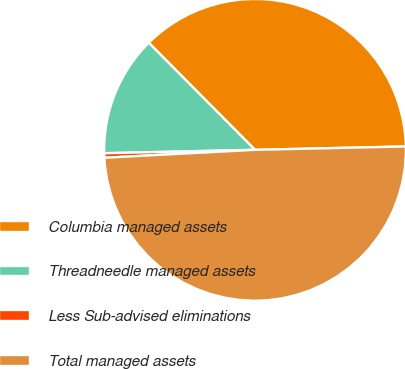Convert chart. <chart><loc_0><loc_0><loc_500><loc_500><pie_chart><fcel>Columbia managed assets<fcel>Threadneedle managed assets<fcel>Less Sub-advised eliminations<fcel>Total managed assets<nl><fcel>37.08%<fcel>12.92%<fcel>0.48%<fcel>49.52%<nl></chart> 